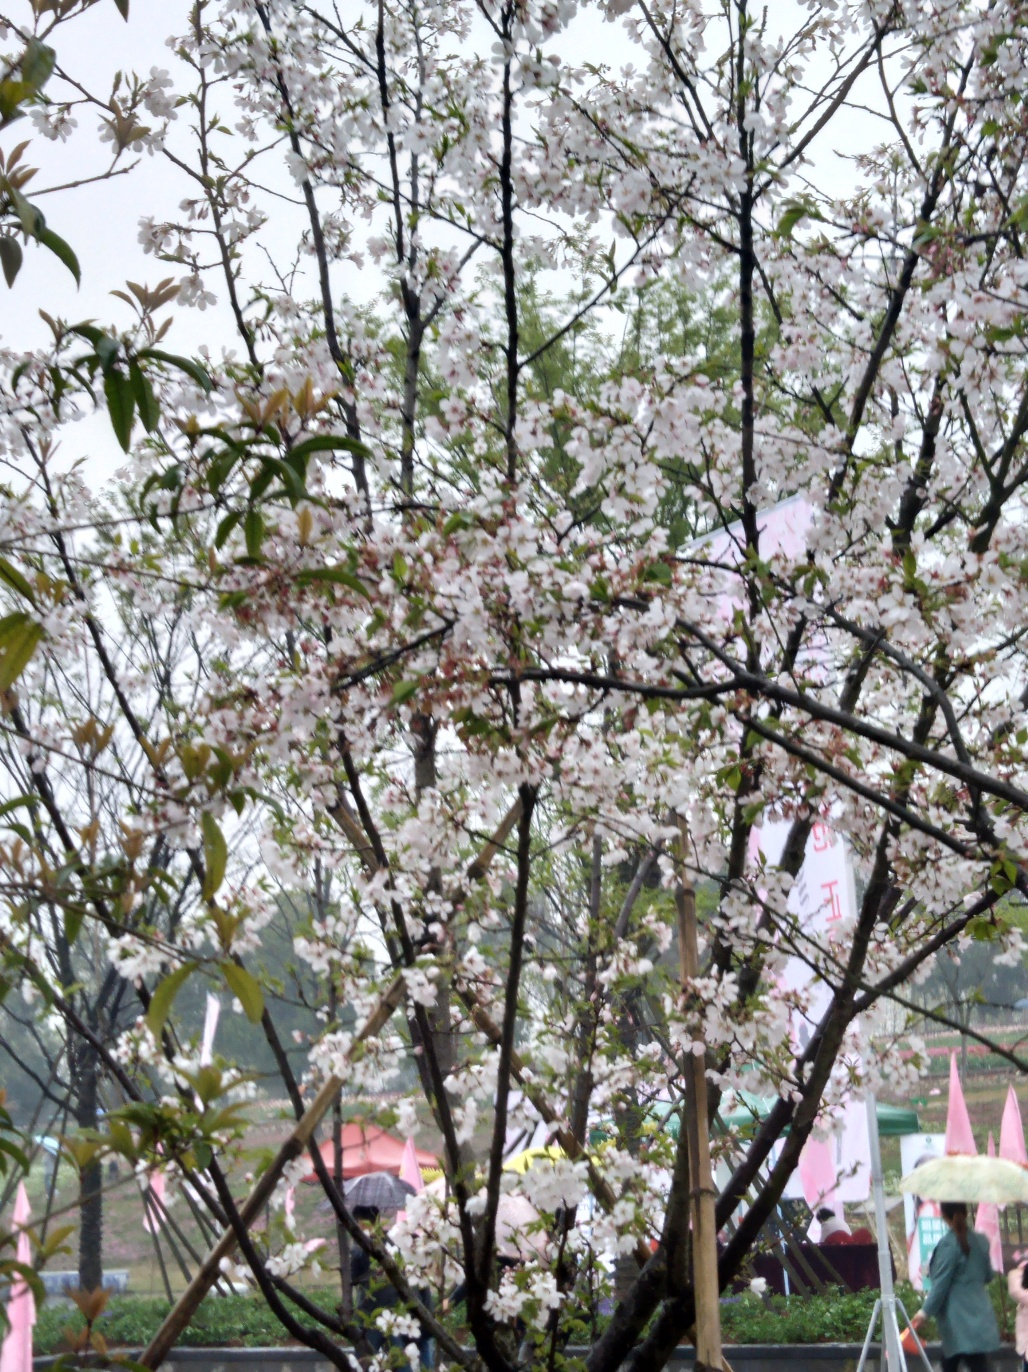Can you describe the atmosphere or mood of this scene? The image captures a serene and contemplative mood, emphasizing the natural beauty and tranquility of a tree in bloom, despite the overcast sky which could indicate an early spring day. The scattering of individuals with umbrellas suggests a gentle rain, adding to the peaceful and somewhat reflective atmosphere. 